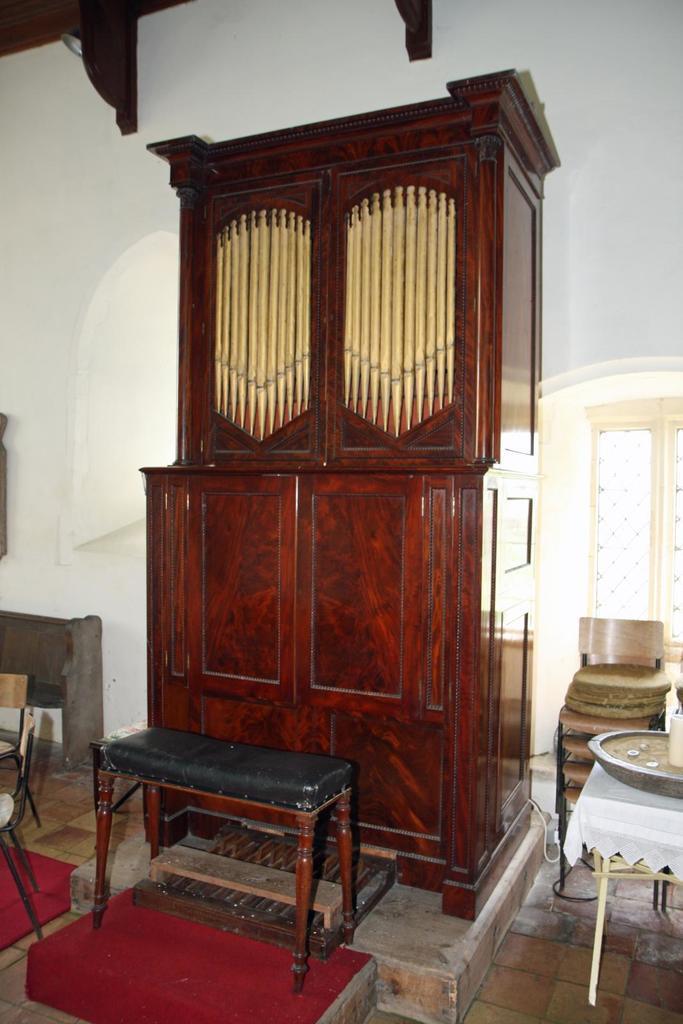Can you describe this image briefly? In this image I can see tables and a cabinet at the back. There is a window at the left and there is a white wall at the back. 